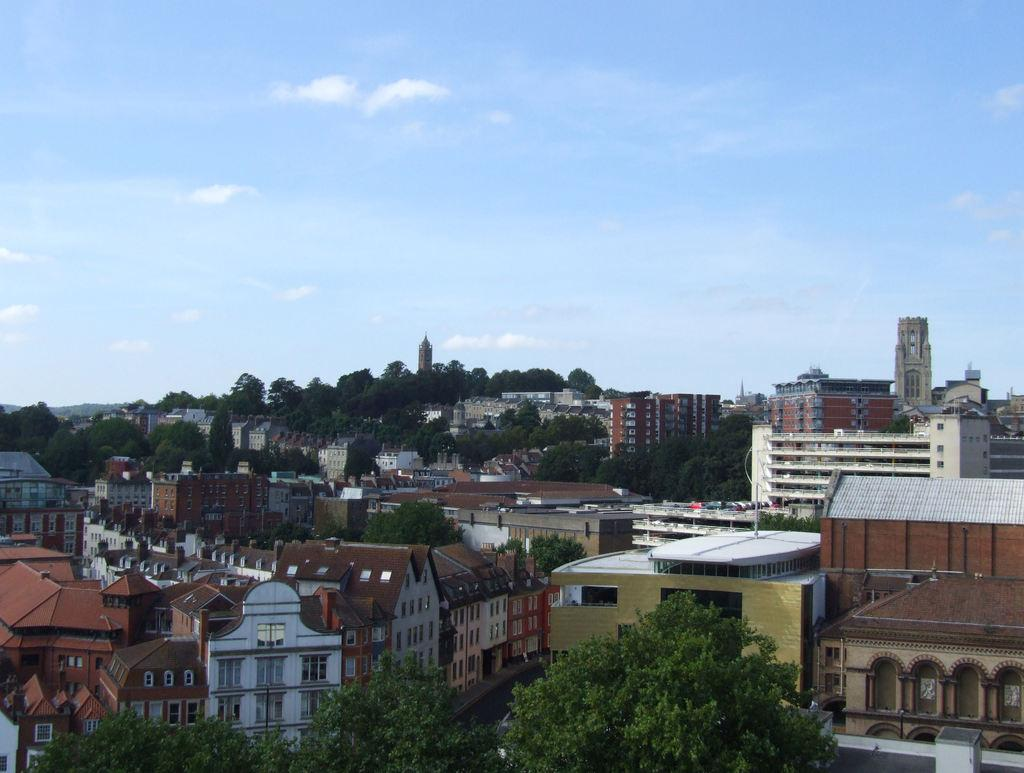What type of location is depicted in the image? The image is of a city. What structures can be seen in the city? There are buildings in the image. Are there any natural elements present in the city? Yes, there are trees in the image. What can be seen in the distance in the image? The sky is visible in the background of the image. How many trucks are parked near the buildings in the image? There are no trucks visible in the image; it only shows buildings, trees, and the sky. What type of credit card is being used to make a purchase in the image? There is no purchase or credit card present in the image. 